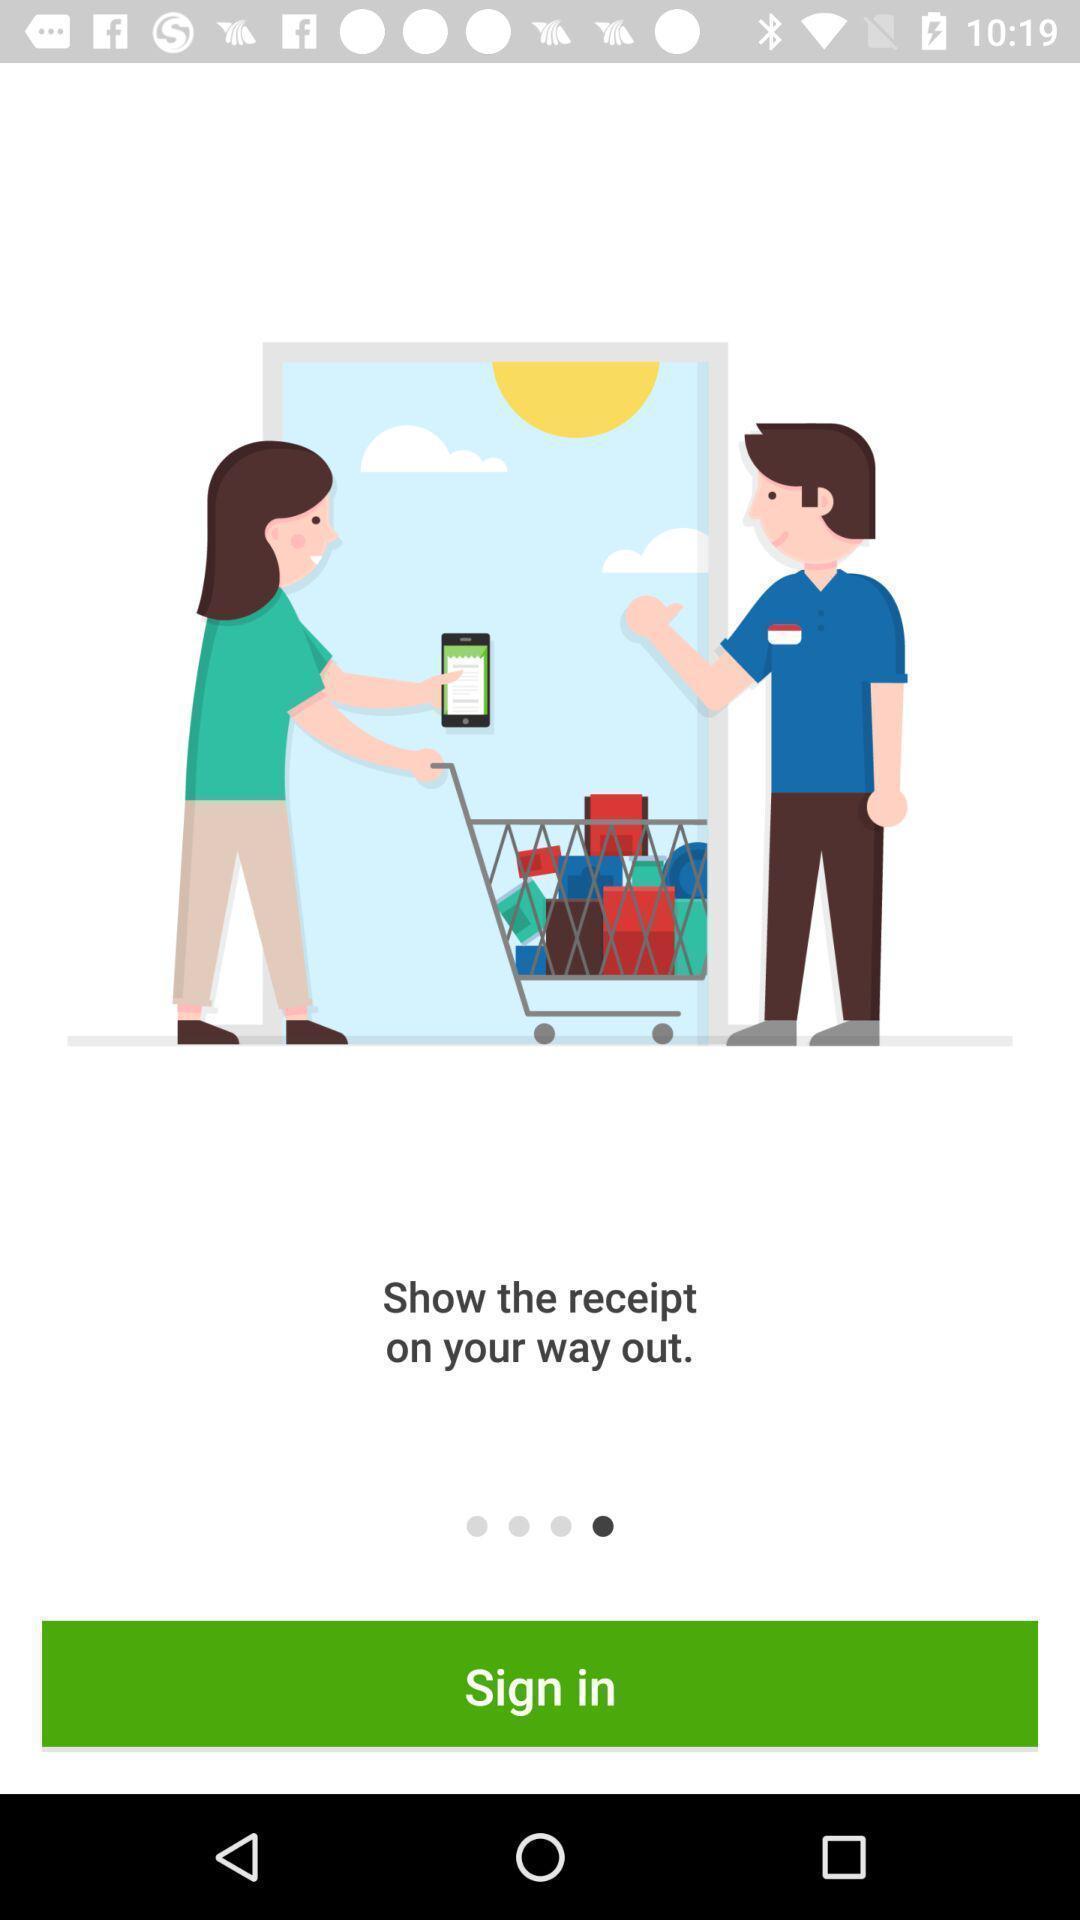Tell me about the visual elements in this screen capture. Sign-in page. 